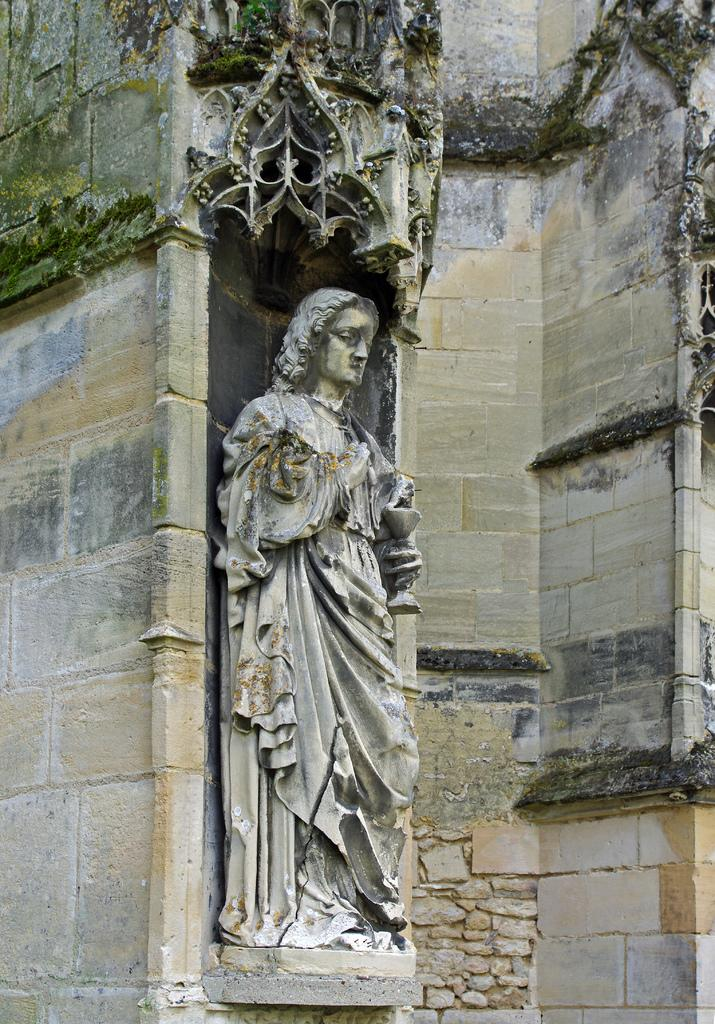What is on the wall in the image? There is a sculpture on the wall in the image. What can be seen at the top of the image? There are designs visible at the top of the image. What type of stick is being used by the person in the image? There is no person present in the image, and therefore no stick being used. 